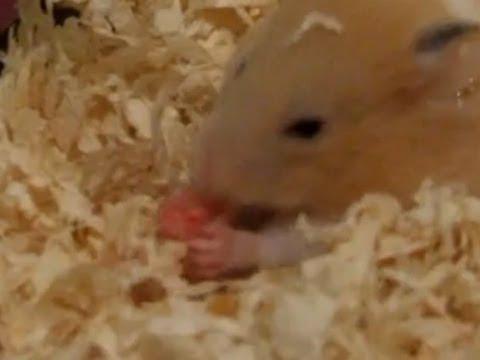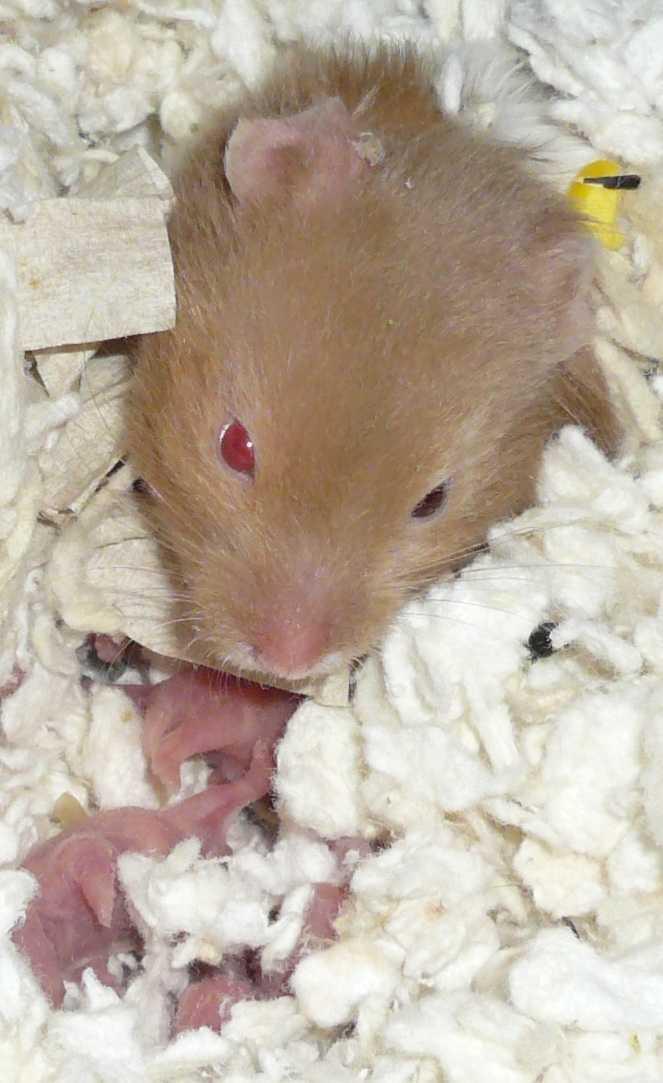The first image is the image on the left, the second image is the image on the right. Considering the images on both sides, is "There are exactly two hamsters" valid? Answer yes or no. Yes. 